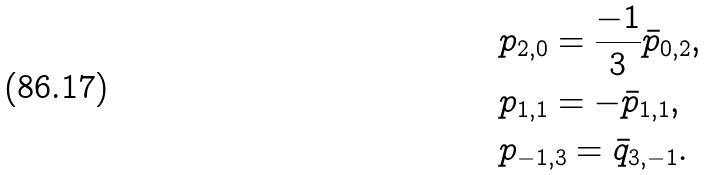<formula> <loc_0><loc_0><loc_500><loc_500>& p _ { 2 , 0 } = \frac { - 1 } { 3 } \bar { p } _ { 0 , 2 } , \\ & p _ { 1 , 1 } = - \bar { p } _ { 1 , 1 } , \\ & p _ { - 1 , 3 } = \bar { q } _ { 3 , - 1 } .</formula> 